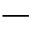<formula> <loc_0><loc_0><loc_500><loc_500>-</formula> 